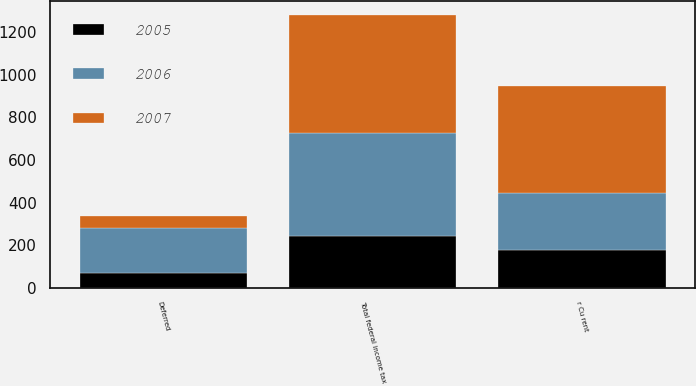<chart> <loc_0><loc_0><loc_500><loc_500><stacked_bar_chart><ecel><fcel>r Cu rent<fcel>Deferred<fcel>Total federal income tax<nl><fcel>2007<fcel>499<fcel>54<fcel>553<nl><fcel>2006<fcel>270<fcel>213<fcel>483<nl><fcel>2005<fcel>176<fcel>68<fcel>244<nl></chart> 